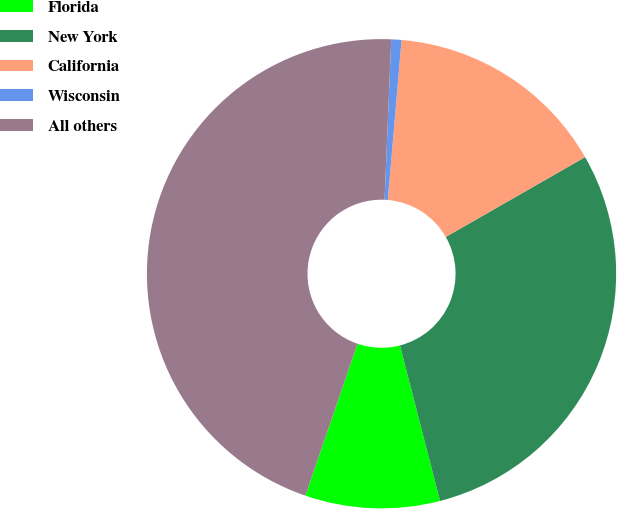<chart> <loc_0><loc_0><loc_500><loc_500><pie_chart><fcel>Florida<fcel>New York<fcel>California<fcel>Wisconsin<fcel>All others<nl><fcel>9.27%<fcel>29.27%<fcel>15.36%<fcel>0.7%<fcel>45.4%<nl></chart> 